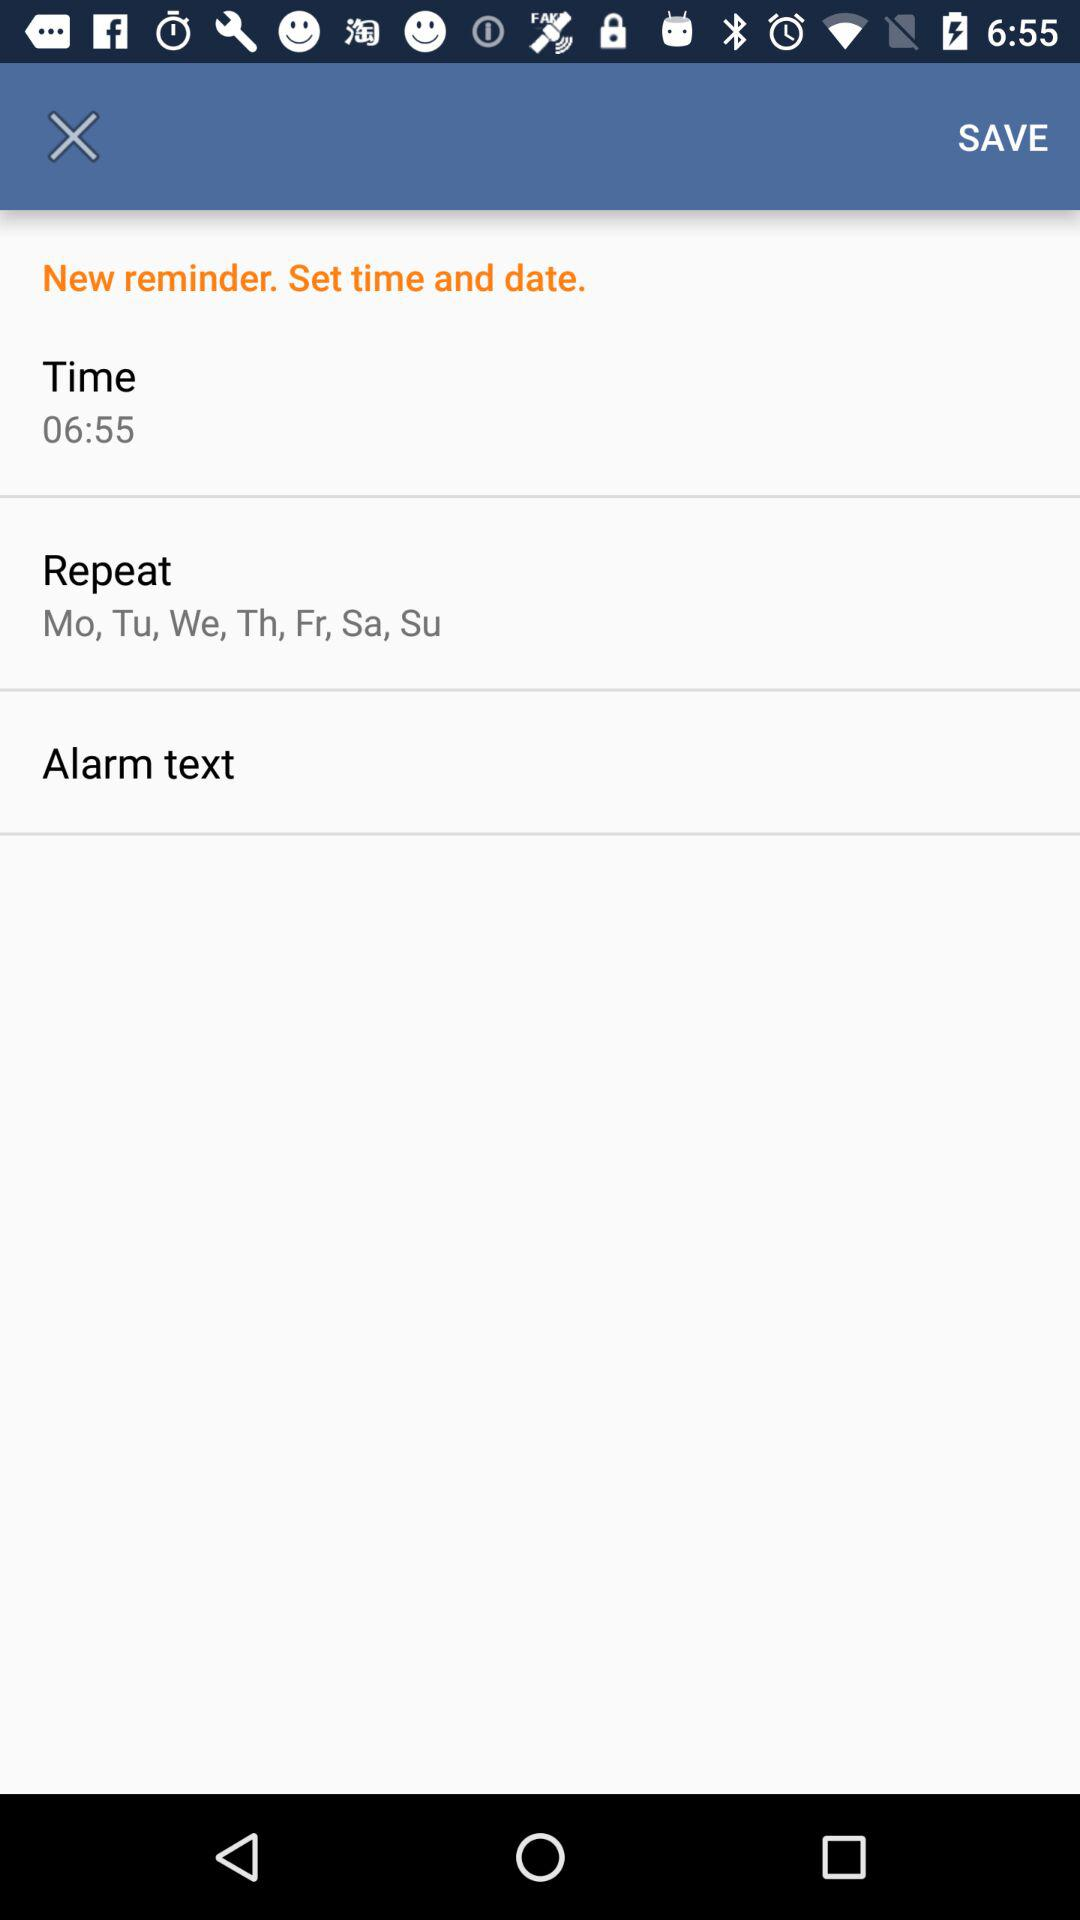What are the days on which the alarm will repeat? The days on which the alarm will repeat are Monday, Tuesday, Wednesday, Thursday, Friday, Saturday and Sunday. 